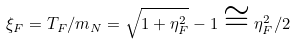Convert formula to latex. <formula><loc_0><loc_0><loc_500><loc_500>\xi _ { F } = T _ { F } / m _ { N } = \sqrt { 1 + \eta _ { F } ^ { 2 } } - 1 \cong \eta _ { F } ^ { 2 } / 2</formula> 